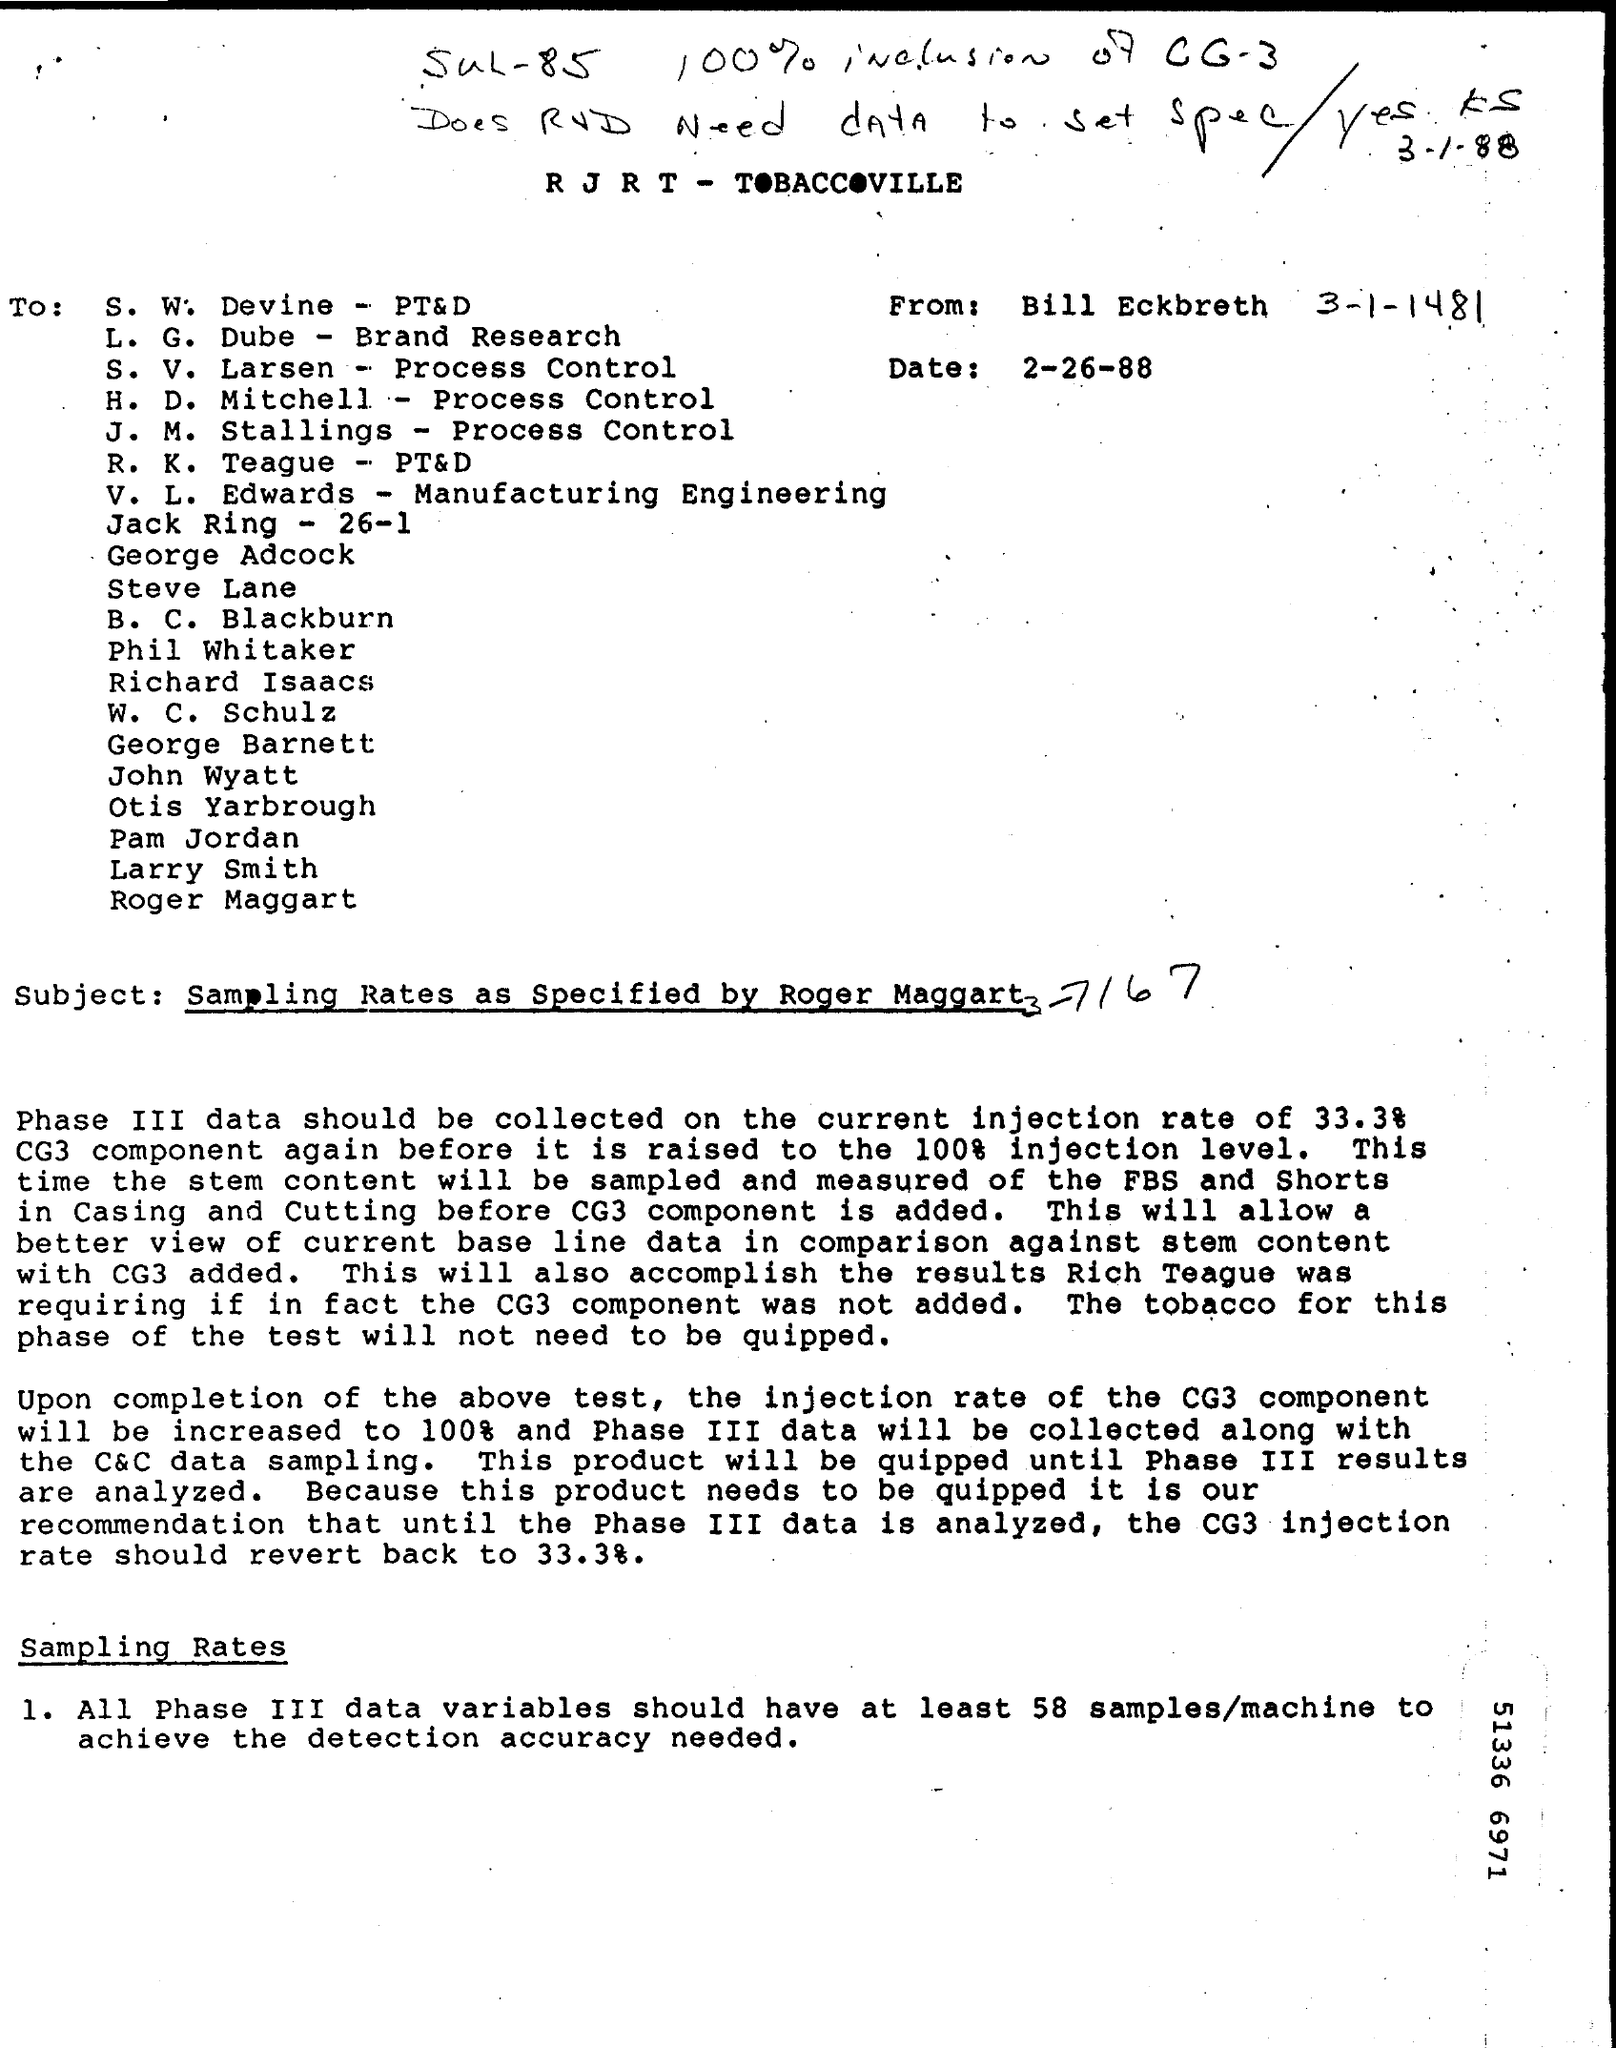What is the subject of the document?
Provide a succinct answer. Sampling Rates as Specified by Roger Maggart. When is the document dated?
Your answer should be very brief. 2-26-88. 